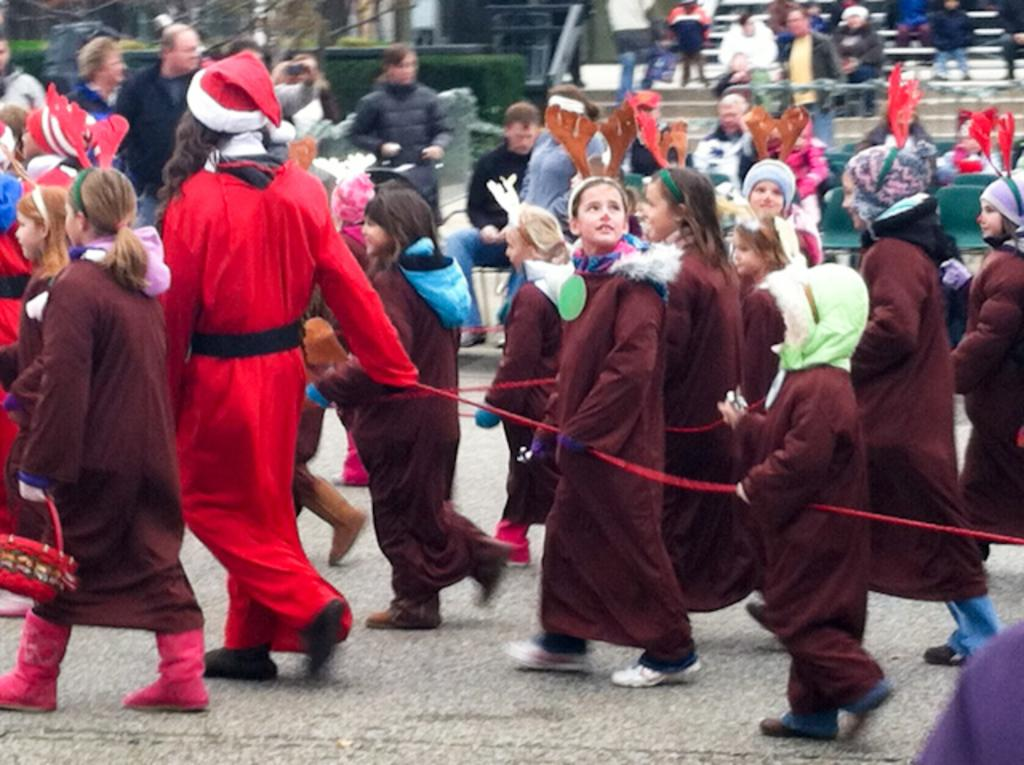Who is present in the image? There are people and kids in the image. What are the people and kids doing in the image? The people and kids are walking on the road. Can you describe any additional features in the image? There is a rope visible in the image, as well as stairs, trees, and plants. Are there any accessories being worn by the people in the image? Some people in the image are wearing caps. What type of wool can be seen on the seashore in the image? There is no wool or seashore present in the image. Is there a volcano visible in the image? No, there is no volcano present in the image. 